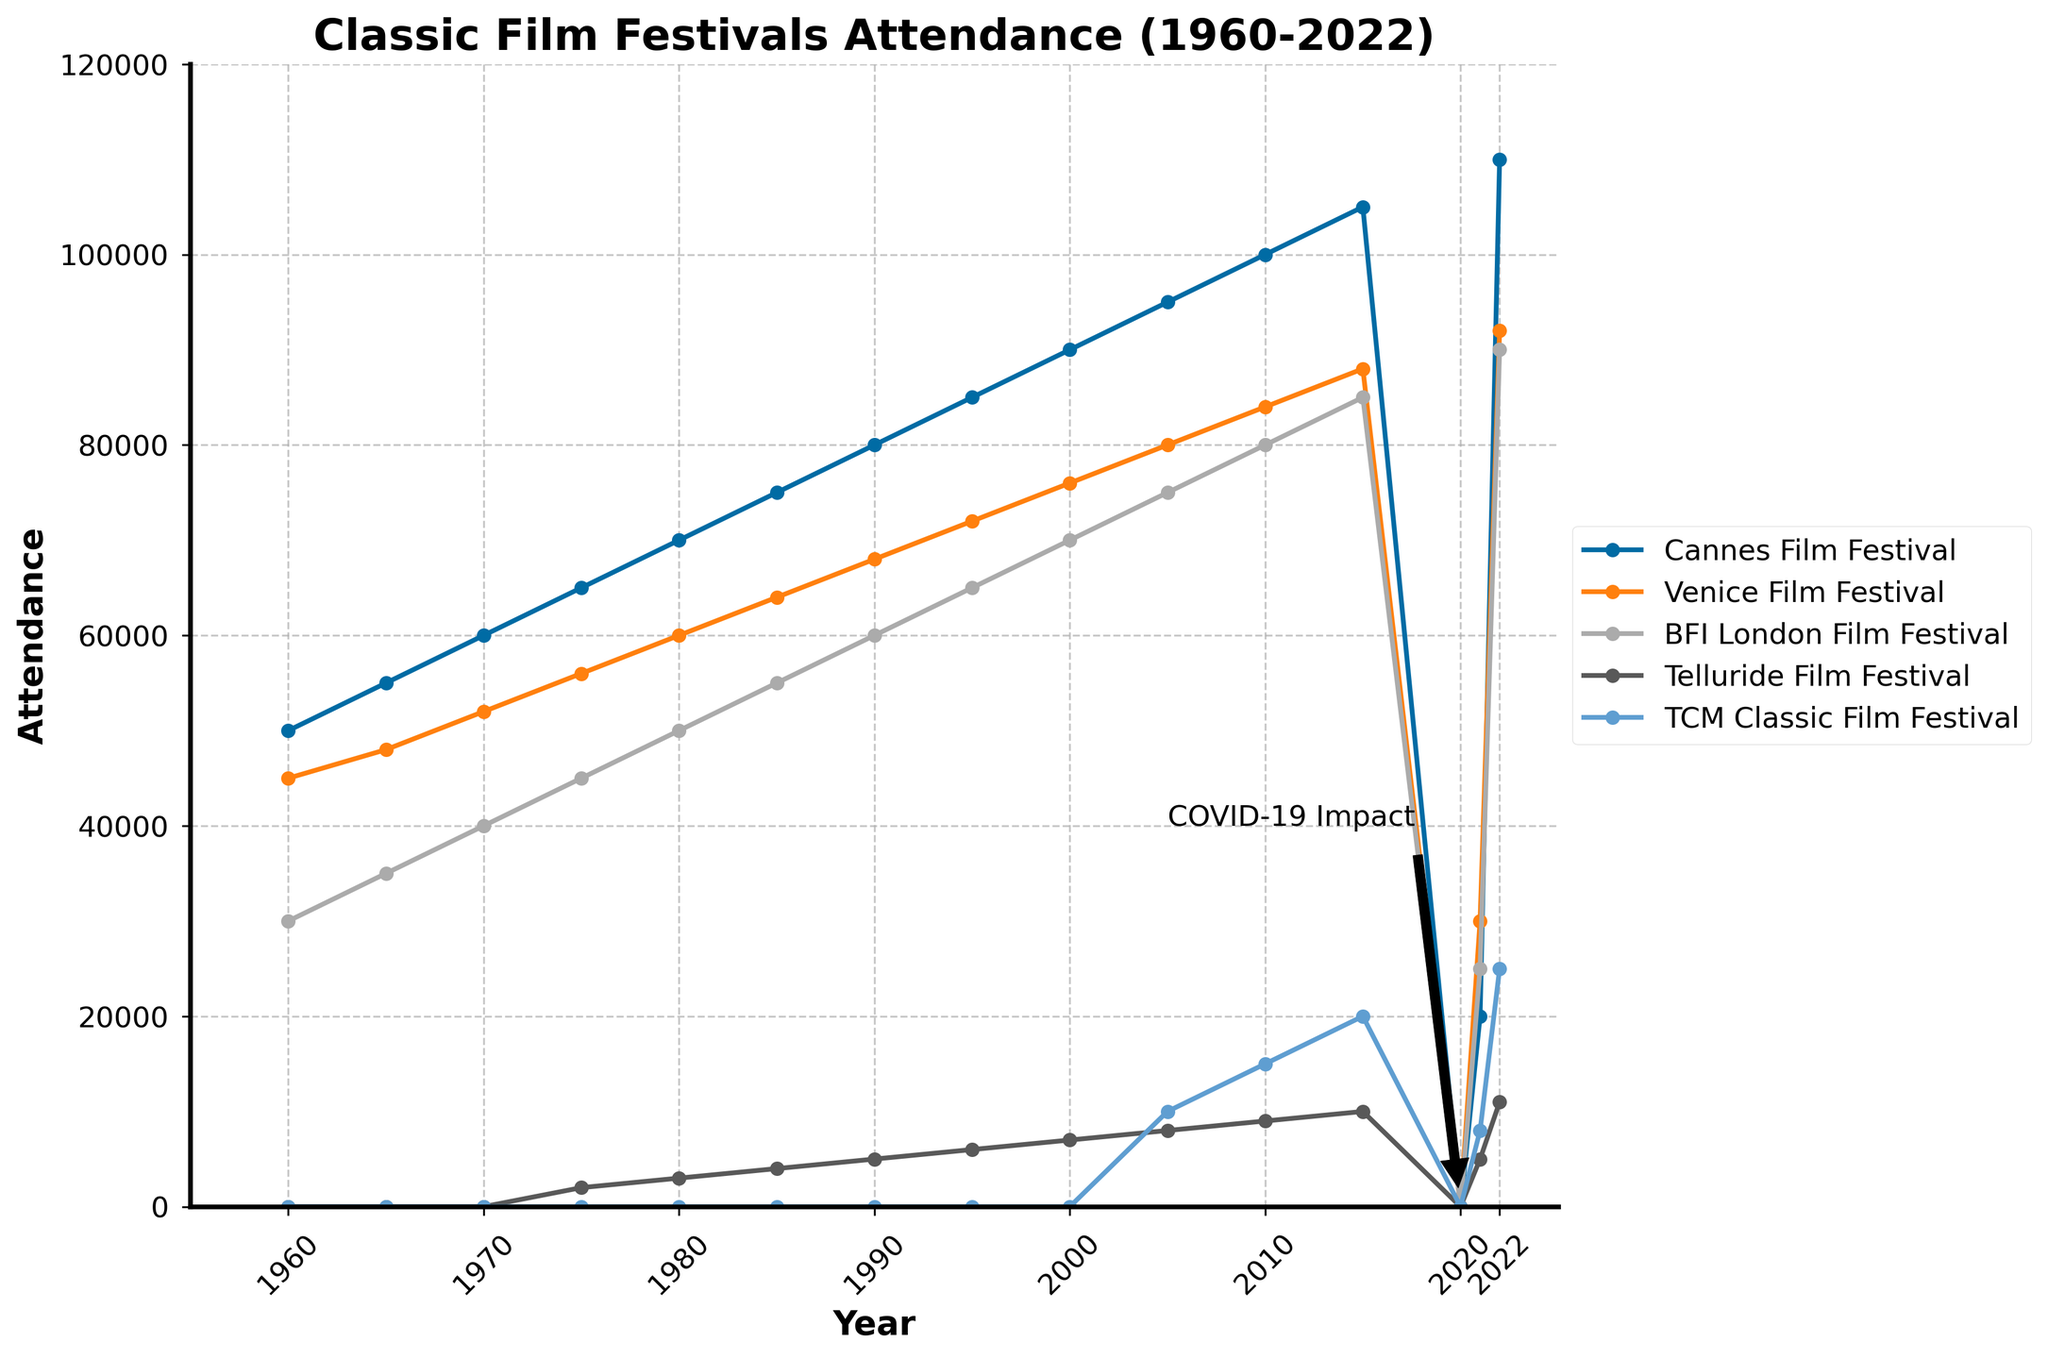Which festival had the highest attendance in 2022? The chart shows the data for five different film festivals. By identifying the data points for the year 2022, one can see that the Cannes Film Festival had the highest attendance, indicated by the tallest data point.
Answer: Cannes Film Festival Did the BFI London Film Festival ever have higher attendance than the Cannes Film Festival? The BFI London Film Festival's highest attendance in 2022 was 90,000, whereas the Cannes Film Festival reached 110,000 the same year. The Cannes Film Festival has consistently higher attendance compared to the BFI London Festival across all years shown.
Answer: No What was the impact of COVID-19 on annual attendances? The chart shows a significant drop to zero attendance for all festivals in 2020, followed by a steep reduction in 2021 before rebounding in 2022. This can be attributed to the impact of COVID-19 pandemic.
Answer: Zero attendance in 2020, steep reduction in 2021 What are the overall trends in attendance for the Telluride Film Festival from its inception? The Telluride Film Festival started in 1975 with an attendance of 2,000, and has shown a general upward trend reaching 11,000 in 2022, indicated by the rising curve.
Answer: Increasing Which festival had the most consistent growth in attendance from 1960 to 2022? The Cannes Film Festival shows the most consistent growth in attendance, with a steady increase over the years without major fluctuations, as indicated by the smooth and steadily upward-sloping line.
Answer: Cannes Film Festival Compare the attendance of all festivals in the year 2005. The year 2005 attendance figures can be directly read off the chart: Cannes Film Festival (95,000), Venice Film Festival (80,000), BFI London Film Festival (75,000), Telluride Film Festival (8,000), and TCM Classic Film Festival (10,000).
Answer: Cannes > Venice > BFI London > TCM Classic > Telluride 